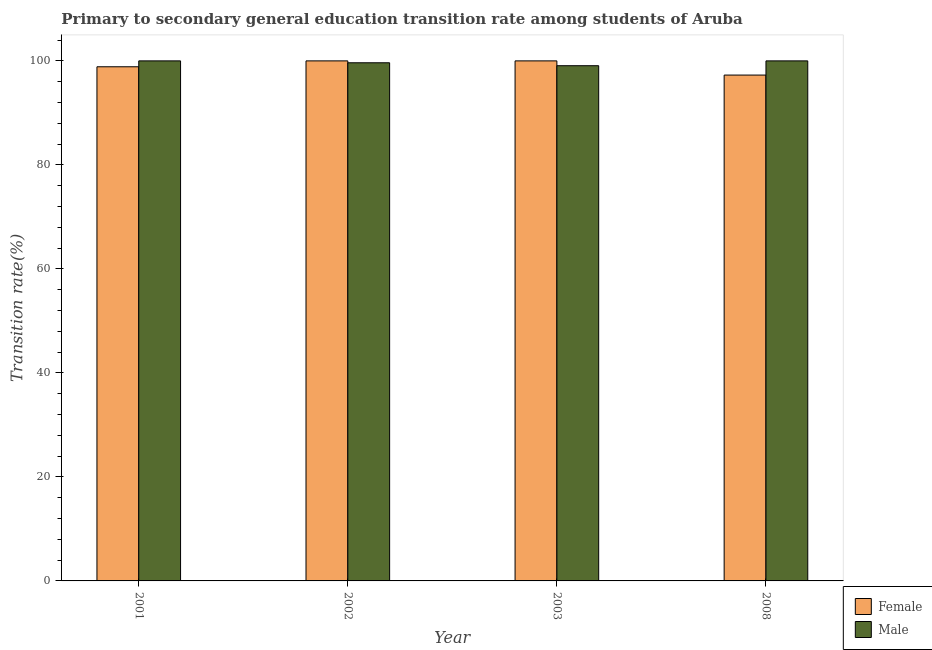How many bars are there on the 1st tick from the left?
Your answer should be compact. 2. How many bars are there on the 2nd tick from the right?
Your answer should be compact. 2. What is the transition rate among female students in 2001?
Provide a succinct answer. 98.87. Across all years, what is the maximum transition rate among female students?
Offer a terse response. 100. Across all years, what is the minimum transition rate among male students?
Make the answer very short. 99.07. In which year was the transition rate among female students maximum?
Ensure brevity in your answer.  2002. What is the total transition rate among female students in the graph?
Ensure brevity in your answer.  396.14. What is the difference between the transition rate among female students in 2008 and the transition rate among male students in 2003?
Your answer should be compact. -2.73. What is the average transition rate among male students per year?
Your answer should be compact. 99.68. What is the ratio of the transition rate among female students in 2001 to that in 2002?
Your response must be concise. 0.99. What is the difference between the highest and the second highest transition rate among female students?
Ensure brevity in your answer.  0. What is the difference between the highest and the lowest transition rate among male students?
Offer a terse response. 0.93. What does the 1st bar from the left in 2002 represents?
Your answer should be compact. Female. What does the 2nd bar from the right in 2003 represents?
Your response must be concise. Female. How many bars are there?
Make the answer very short. 8. Are all the bars in the graph horizontal?
Keep it short and to the point. No. What is the difference between two consecutive major ticks on the Y-axis?
Your answer should be compact. 20. Are the values on the major ticks of Y-axis written in scientific E-notation?
Offer a very short reply. No. Does the graph contain any zero values?
Your answer should be compact. No. Does the graph contain grids?
Your answer should be compact. No. Where does the legend appear in the graph?
Make the answer very short. Bottom right. How many legend labels are there?
Your answer should be very brief. 2. What is the title of the graph?
Offer a terse response. Primary to secondary general education transition rate among students of Aruba. What is the label or title of the Y-axis?
Your response must be concise. Transition rate(%). What is the Transition rate(%) in Female in 2001?
Your answer should be very brief. 98.87. What is the Transition rate(%) of Female in 2002?
Keep it short and to the point. 100. What is the Transition rate(%) in Male in 2002?
Ensure brevity in your answer.  99.63. What is the Transition rate(%) of Male in 2003?
Provide a short and direct response. 99.07. What is the Transition rate(%) in Female in 2008?
Your answer should be very brief. 97.27. Across all years, what is the maximum Transition rate(%) in Female?
Your response must be concise. 100. Across all years, what is the minimum Transition rate(%) of Female?
Your answer should be very brief. 97.27. Across all years, what is the minimum Transition rate(%) of Male?
Keep it short and to the point. 99.07. What is the total Transition rate(%) in Female in the graph?
Offer a terse response. 396.14. What is the total Transition rate(%) in Male in the graph?
Provide a succinct answer. 398.7. What is the difference between the Transition rate(%) of Female in 2001 and that in 2002?
Keep it short and to the point. -1.13. What is the difference between the Transition rate(%) of Male in 2001 and that in 2002?
Offer a very short reply. 0.37. What is the difference between the Transition rate(%) in Female in 2001 and that in 2003?
Your response must be concise. -1.13. What is the difference between the Transition rate(%) in Female in 2001 and that in 2008?
Provide a short and direct response. 1.6. What is the difference between the Transition rate(%) of Male in 2001 and that in 2008?
Your answer should be very brief. 0. What is the difference between the Transition rate(%) in Female in 2002 and that in 2003?
Your answer should be compact. 0. What is the difference between the Transition rate(%) of Male in 2002 and that in 2003?
Keep it short and to the point. 0.56. What is the difference between the Transition rate(%) in Female in 2002 and that in 2008?
Your answer should be very brief. 2.73. What is the difference between the Transition rate(%) of Male in 2002 and that in 2008?
Provide a short and direct response. -0.37. What is the difference between the Transition rate(%) of Female in 2003 and that in 2008?
Keep it short and to the point. 2.73. What is the difference between the Transition rate(%) in Male in 2003 and that in 2008?
Your answer should be very brief. -0.93. What is the difference between the Transition rate(%) in Female in 2001 and the Transition rate(%) in Male in 2002?
Your answer should be compact. -0.77. What is the difference between the Transition rate(%) of Female in 2001 and the Transition rate(%) of Male in 2003?
Provide a succinct answer. -0.2. What is the difference between the Transition rate(%) in Female in 2001 and the Transition rate(%) in Male in 2008?
Provide a short and direct response. -1.13. What is the difference between the Transition rate(%) in Female in 2002 and the Transition rate(%) in Male in 2008?
Ensure brevity in your answer.  0. What is the difference between the Transition rate(%) in Female in 2003 and the Transition rate(%) in Male in 2008?
Your answer should be compact. 0. What is the average Transition rate(%) in Female per year?
Make the answer very short. 99.03. What is the average Transition rate(%) in Male per year?
Offer a very short reply. 99.68. In the year 2001, what is the difference between the Transition rate(%) of Female and Transition rate(%) of Male?
Your answer should be very brief. -1.13. In the year 2002, what is the difference between the Transition rate(%) in Female and Transition rate(%) in Male?
Provide a succinct answer. 0.37. In the year 2003, what is the difference between the Transition rate(%) in Female and Transition rate(%) in Male?
Your answer should be compact. 0.93. In the year 2008, what is the difference between the Transition rate(%) of Female and Transition rate(%) of Male?
Your response must be concise. -2.73. What is the ratio of the Transition rate(%) of Female in 2001 to that in 2002?
Make the answer very short. 0.99. What is the ratio of the Transition rate(%) in Male in 2001 to that in 2002?
Your answer should be compact. 1. What is the ratio of the Transition rate(%) in Female in 2001 to that in 2003?
Your response must be concise. 0.99. What is the ratio of the Transition rate(%) in Male in 2001 to that in 2003?
Make the answer very short. 1.01. What is the ratio of the Transition rate(%) in Female in 2001 to that in 2008?
Your answer should be very brief. 1.02. What is the ratio of the Transition rate(%) of Male in 2001 to that in 2008?
Ensure brevity in your answer.  1. What is the ratio of the Transition rate(%) of Female in 2002 to that in 2008?
Make the answer very short. 1.03. What is the ratio of the Transition rate(%) in Male in 2002 to that in 2008?
Give a very brief answer. 1. What is the ratio of the Transition rate(%) in Female in 2003 to that in 2008?
Offer a terse response. 1.03. What is the ratio of the Transition rate(%) of Male in 2003 to that in 2008?
Keep it short and to the point. 0.99. What is the difference between the highest and the lowest Transition rate(%) of Female?
Offer a very short reply. 2.73. What is the difference between the highest and the lowest Transition rate(%) of Male?
Your answer should be compact. 0.93. 